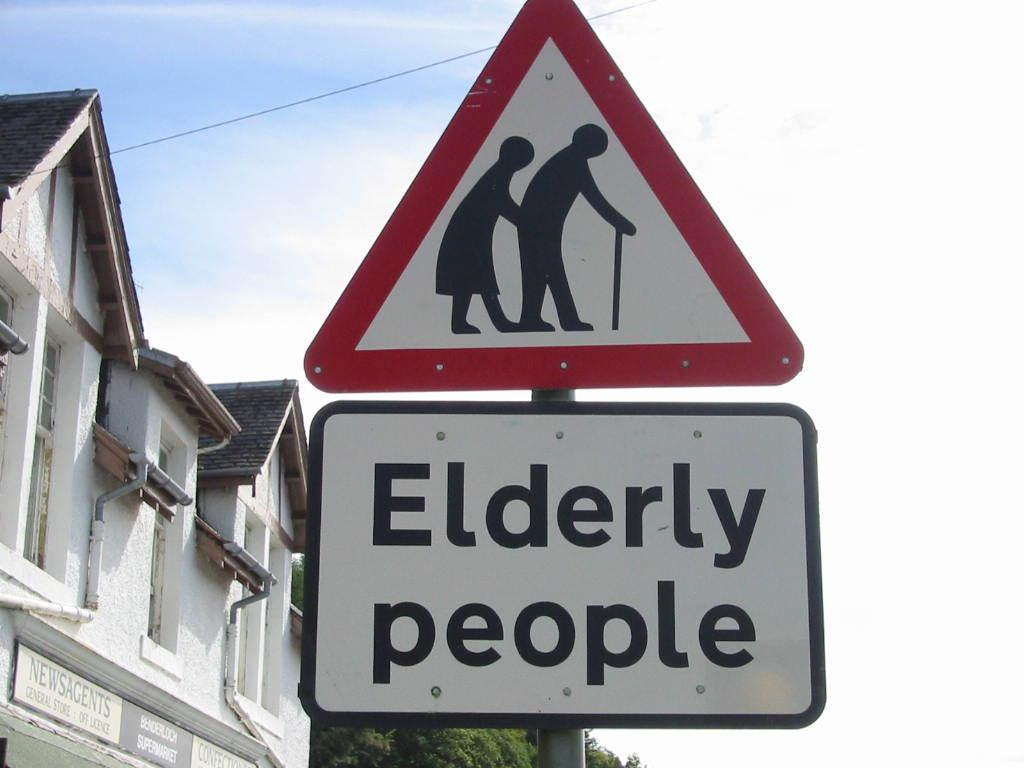<image>
Give a short and clear explanation of the subsequent image. A sign is posted to show that elderly people are in the area. 